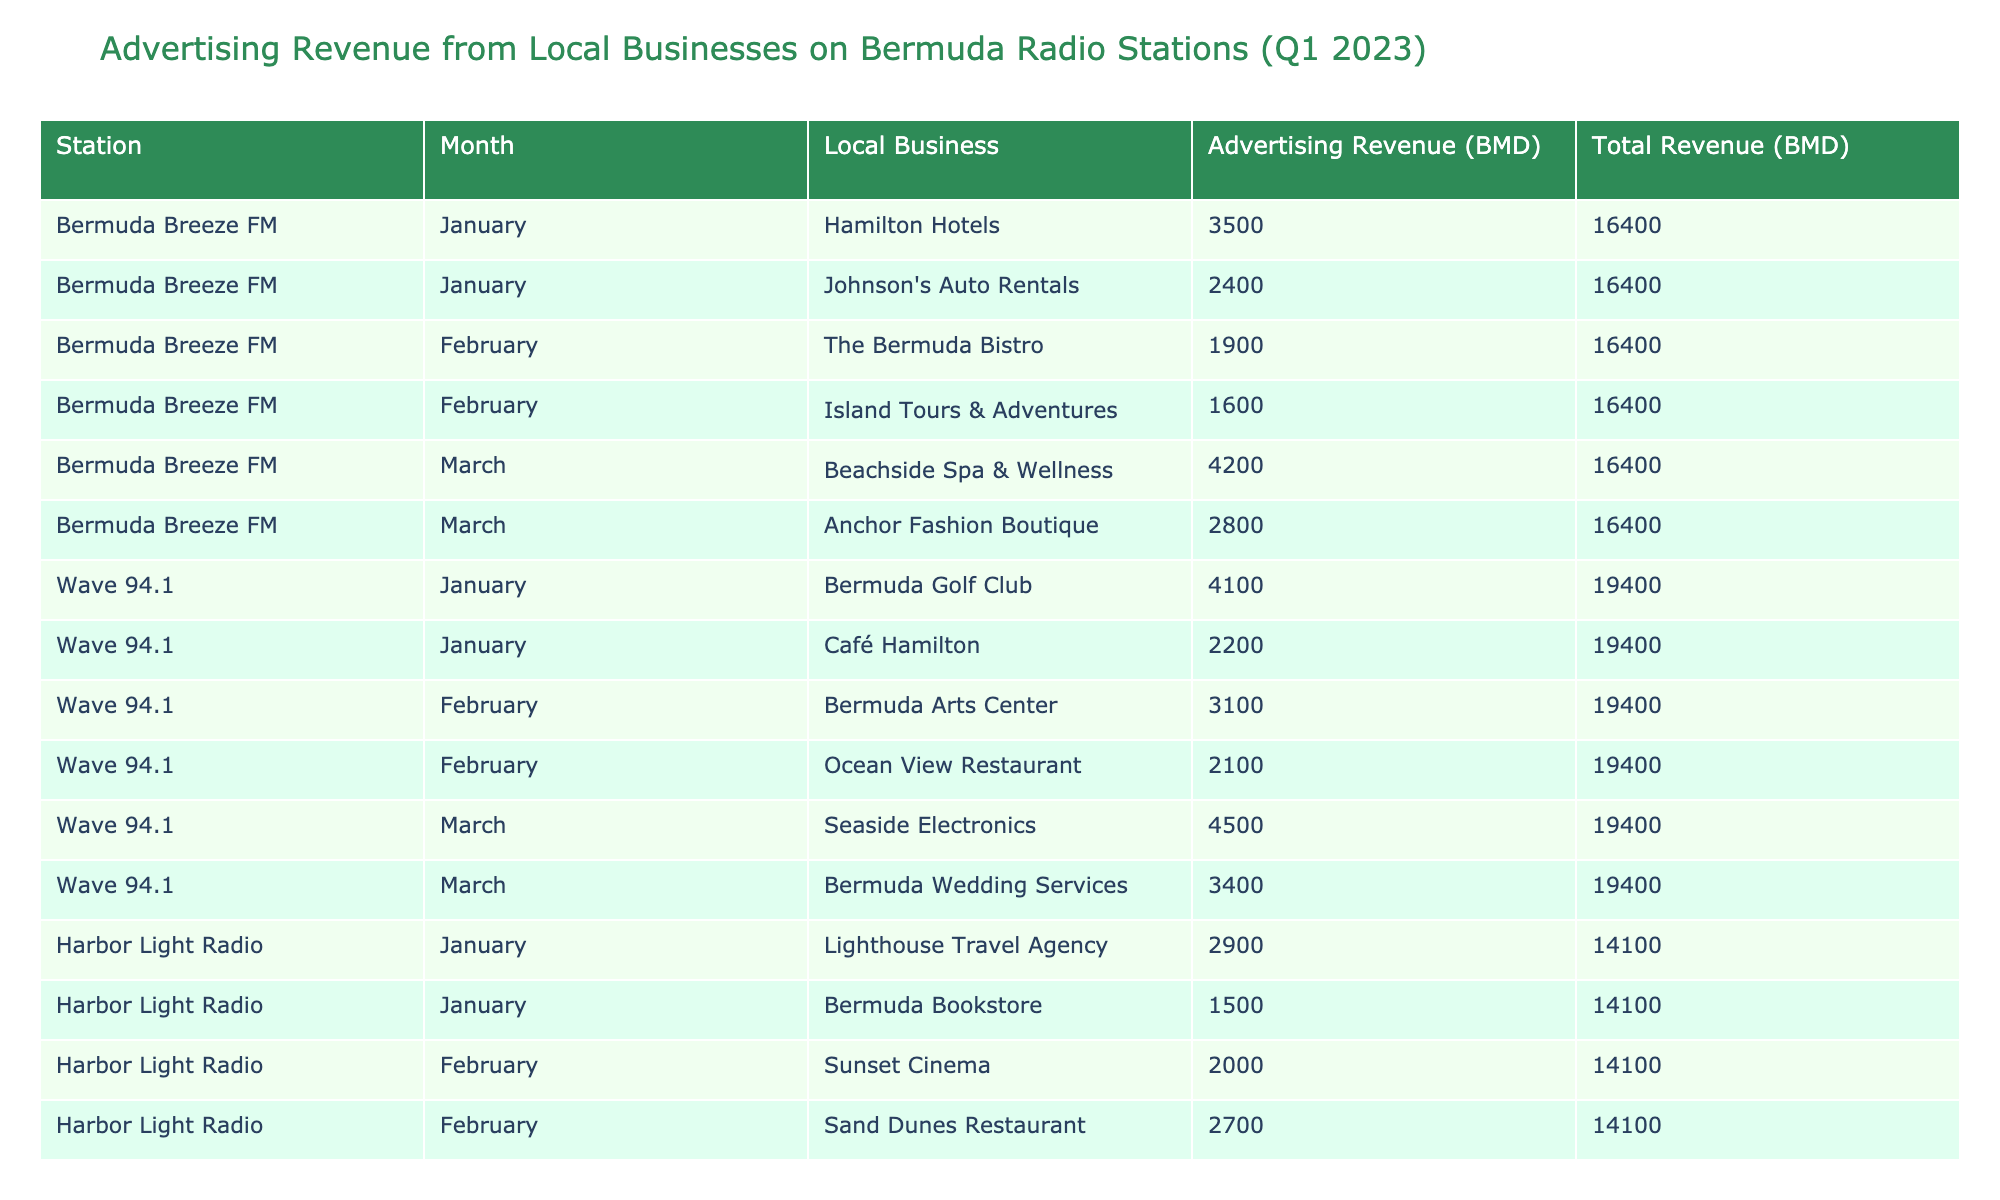What was the total advertising revenue for Wave 94.1 in February? The advertising revenue for Wave 94.1 in February is the sum of the revenues from Bermuda Arts Center (3100) and Ocean View Restaurant (2100). Adding these values together gives 3100 + 2100 = 5200.
Answer: 5200 Which local business had the highest advertising revenue in March? In March, the highest revenue comes from Beachside Spa & Wellness at Bermuda Breeze FM with 4200. Comparing this value to the other entries shows that it surpasses the revenue of the other local businesses for that month.
Answer: Beachside Spa & Wellness Did Harbor Light Radio receive more revenue from local businesses in January than in February? In January, the total revenue from Harbor Light Radio was 2900 (Lighthouse Travel Agency) + 1500 (Bermuda Bookstore) = 4400. In February, the revenue was 2000 (Sunset Cinema) + 2700 (Sand Dunes Restaurant) = 4700. Thus, January's total (4400) is less than February's total (4700).
Answer: No What is the average advertising revenue for Bermuda Breeze FM for Q1 2023? For Bermuda Breeze FM, the values are 3500 (January) + 1900 (February) + 4200 (March) = 9600. There are three months, so the average is 9600 divided by 3, which equals 3200.
Answer: 3200 Was Johnson's Auto Rentals the only business to advertise during January on Bermuda Breeze FM? From the table, January shows two local businesses that advertised on Bermuda Breeze FM: Hamilton Hotels and Johnson's Auto Rentals. Therefore, it is incorrect to say Johnson's Auto Rentals was the only one.
Answer: No What is the total revenue earned by Wave 94.1 in the first quarter? The total for Wave 94.1 is calculated by adding revenues across January (4100 + 2200), February (3100 + 2100), and March (4500 + 3400). This gives 4100 + 2200 + 3100 + 2100 + 4500 + 3400 = 18800 for the quarter.
Answer: 18800 Which station earned the least total revenue for Q1 2023? To determine the least revenue, I need to sum up the revenues for each station. Bermuda Breeze FM: 3500 + 1900 + 4200 = 9600. Wave 94.1: 18800. Harbor Light Radio: 2900 + 1500 + 2000 + 2700 + 3600 + 1400 = 18600. Comparing these totals shows that Bermuda Breeze FM has the least revenue.
Answer: Bermuda Breeze FM Which station had the highest revenue from advertising in January? In January, Bermuda Breeze FM earned 3500 (Hamilton Hotels) + 2400 (Johnson's Auto Rentals) = 5900. Wave 94.1 earned 4100 (Bermuda Golf Club) + 2200 (Café Hamilton) = 6300. Harbor Light Radio earned 2900 + 1500 = 4400. Wave 94.1 has the highest revenue in January with 6300.
Answer: Wave 94.1 